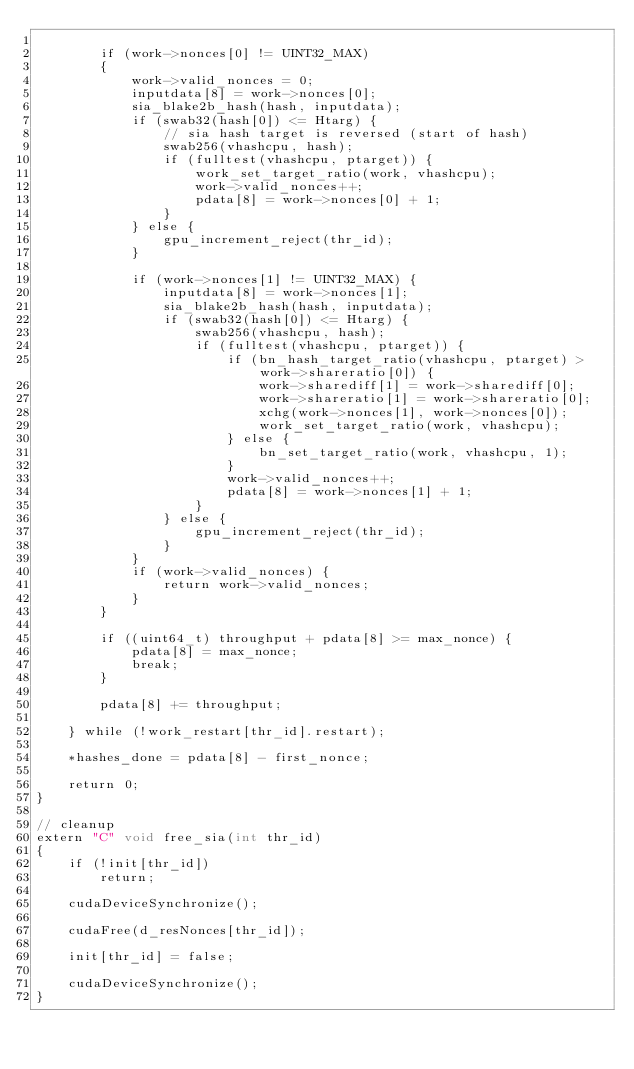Convert code to text. <code><loc_0><loc_0><loc_500><loc_500><_Cuda_>
		if (work->nonces[0] != UINT32_MAX)
		{
			work->valid_nonces = 0;
			inputdata[8] = work->nonces[0];
			sia_blake2b_hash(hash, inputdata);
			if (swab32(hash[0]) <= Htarg) {
				// sia hash target is reversed (start of hash)
				swab256(vhashcpu, hash);
				if (fulltest(vhashcpu, ptarget)) {
					work_set_target_ratio(work, vhashcpu);
					work->valid_nonces++;
					pdata[8] = work->nonces[0] + 1;
				}
			} else {
				gpu_increment_reject(thr_id);
			}

			if (work->nonces[1] != UINT32_MAX) {
				inputdata[8] = work->nonces[1];
				sia_blake2b_hash(hash, inputdata);
				if (swab32(hash[0]) <= Htarg) {
					swab256(vhashcpu, hash);
					if (fulltest(vhashcpu, ptarget)) {
						if (bn_hash_target_ratio(vhashcpu, ptarget) > work->shareratio[0]) {
							work->sharediff[1] = work->sharediff[0];
							work->shareratio[1] = work->shareratio[0];
							xchg(work->nonces[1], work->nonces[0]);
							work_set_target_ratio(work, vhashcpu);
						} else {
							bn_set_target_ratio(work, vhashcpu, 1);
						}
						work->valid_nonces++;
						pdata[8] = work->nonces[1] + 1;
					}
				} else {
					gpu_increment_reject(thr_id);
				}
			}
			if (work->valid_nonces) {
				return work->valid_nonces;
			}
		}

		if ((uint64_t) throughput + pdata[8] >= max_nonce) {
			pdata[8] = max_nonce;
			break;
		}

		pdata[8] += throughput;

	} while (!work_restart[thr_id].restart);

	*hashes_done = pdata[8] - first_nonce;

	return 0;
}

// cleanup
extern "C" void free_sia(int thr_id)
{
	if (!init[thr_id])
		return;

	cudaDeviceSynchronize();

	cudaFree(d_resNonces[thr_id]);

	init[thr_id] = false;

	cudaDeviceSynchronize();
}
</code> 